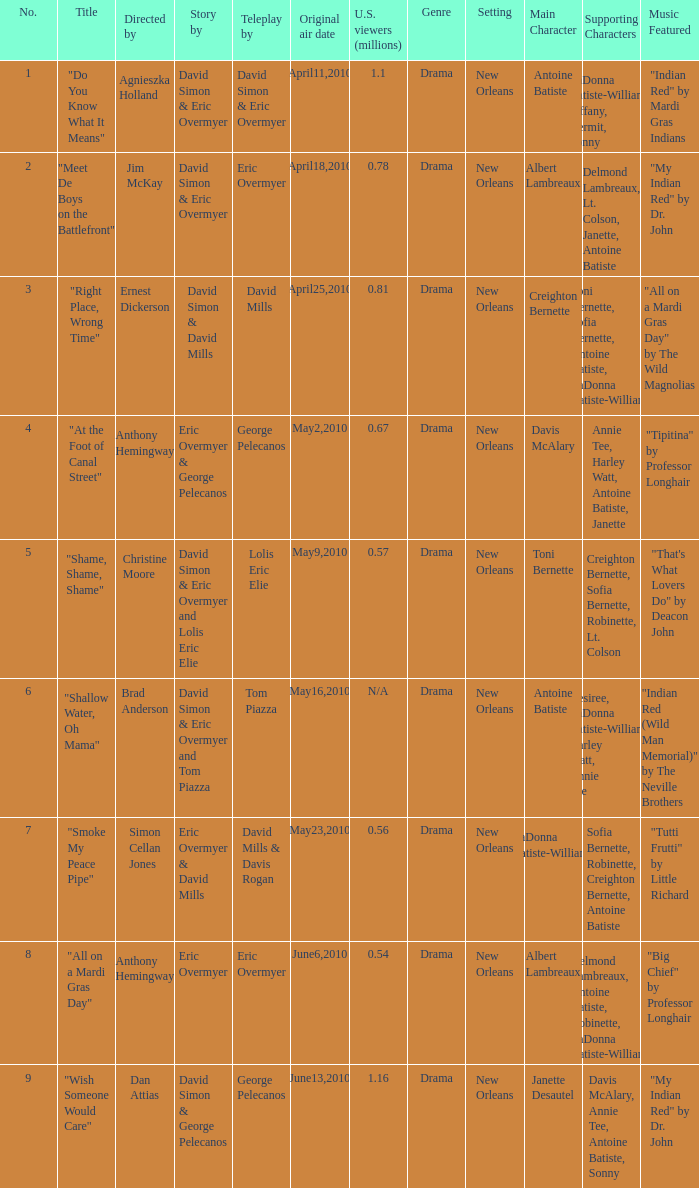Name the teleplay for  david simon & eric overmyer and tom piazza Tom Piazza. 